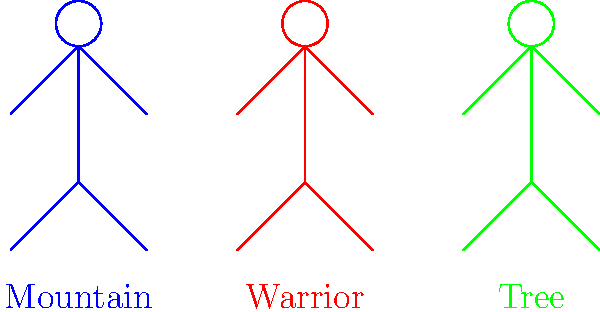Which of the three yoga poses illustrated above is known for improving balance and concentration, and is often recommended for beginners to practice near a wall for support? Let's analyze each of the yoga poses illustrated in the diagram:

1. Mountain Pose (blue figure):
   - This is a standing pose with feet together and arms at the sides.
   - Benefits: Improves posture and body awareness.
   - Not specifically known for balance challenges.

2. Warrior Pose (red figure):
   - This pose involves a lunging stance with arms extended.
   - Benefits: Strengthens legs and core, improves stability.
   - While it does improve balance, it's not typically the first pose recommended for beginners focusing on balance.

3. Tree Pose (green figure):
   - This pose involves standing on one leg with the other foot placed on the inner thigh or calf.
   - Benefits: Improves balance, concentration, and focus.
   - Often recommended for beginners to practice near a wall for support.

The Tree Pose (green figure) is specifically known for its balance-improving properties and is frequently suggested for beginners to practice with wall support. It requires focusing on a single point to maintain balance, which enhances concentration.
Answer: Tree Pose 